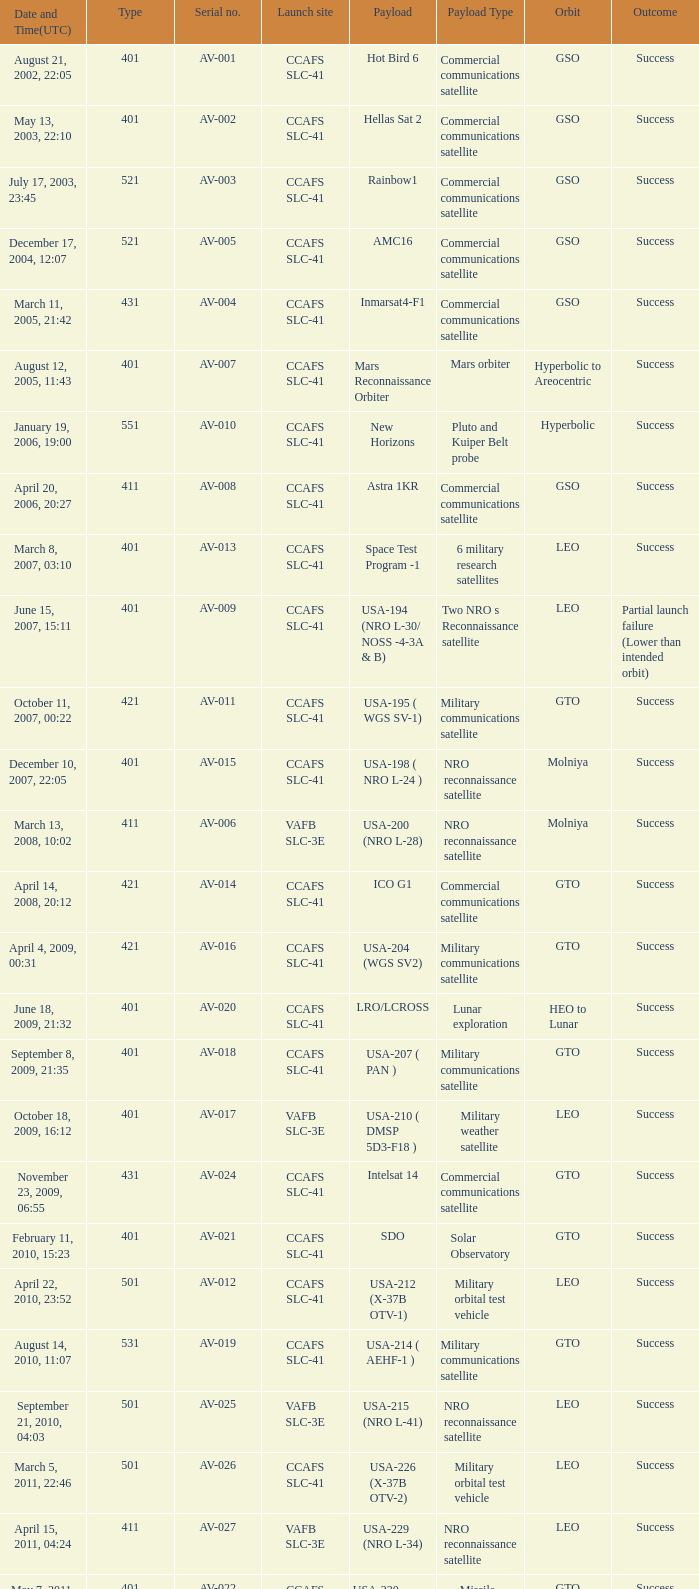What payload was on November 26, 2011, 15:02? Mars rover. 